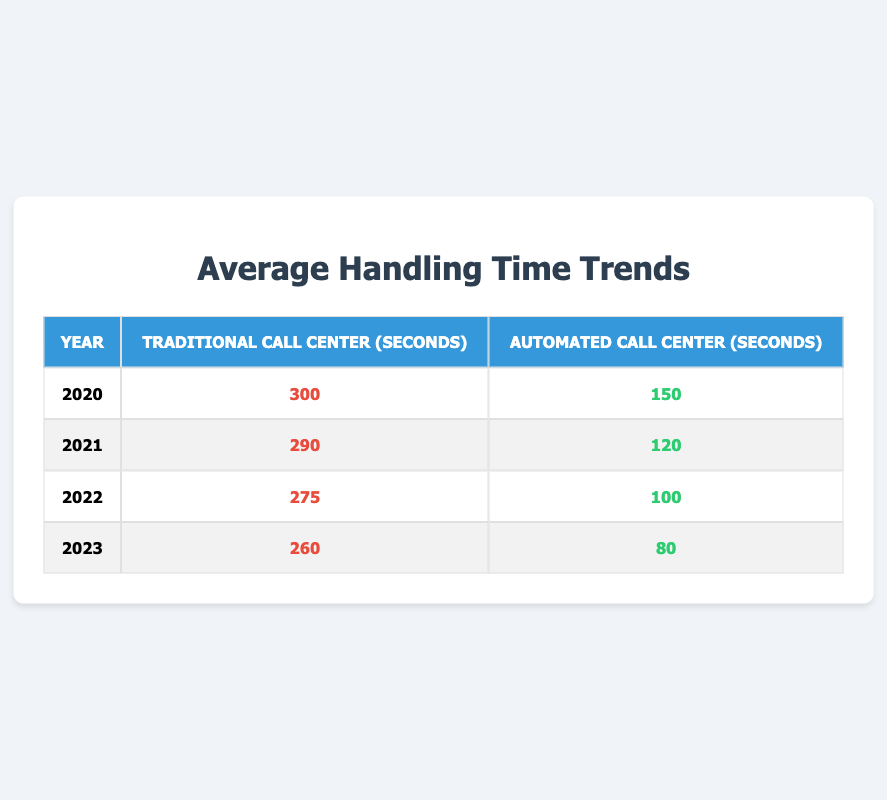What was the Average Handling Time for the Traditional Call Center in 2022? According to the table, the Average Handling Time for the Traditional Call Center in 2022 is listed as 275 seconds.
Answer: 275 seconds What was the Average Handling Time for the Automated Call Center in 2021? The table shows that the Average Handling Time for the Automated Call Center in 2021 is 120 seconds.
Answer: 120 seconds In which year did the Automated Call Center have its lowest Average Handling Time? The table indicates that the Automated Call Center had its lowest Average Handling Time in 2023, with a value of 80 seconds.
Answer: 2023 What is the difference in Average Handling Time between Traditional and Automated Call Centers in 2020? In 2020, the Average Handling Time for the Traditional Call Center was 300 seconds and for the Automated Call Center was 150 seconds. The difference is 300 - 150 = 150 seconds.
Answer: 150 seconds What is the average Average Handling Time for the Traditional Call Center over the years presented? The values for the Traditional Call Center are 300, 290, 275, and 260 seconds. The average is (300 + 290 + 275 + 260) / 4 = 271.25 seconds.
Answer: 271.25 seconds Is the Average Handling Time for the Automated Call Center lower in 2023 compared to 2021? The Automated Call Center had an Average Handling Time of 80 seconds in 2023 and 120 seconds in 2021. Since 80 < 120, the statement is true.
Answer: Yes What trend can be observed in the Average Handling Time for both call center types over the years? The table shows that both call center types have a downward trend in Average Handling Time from 2020 to 2023. For Traditional, it decreased from 300 to 260 seconds, and for Automated, it decreased from 150 to 80 seconds.
Answer: A downward trend What was the Average Handling Time for both types of call centers combined in 2022? To find the combined Average Handling Time in 2022, we compute the average of 275 seconds for Traditional and 100 seconds for Automated, which totals (275 + 100) / 2 = 187.5 seconds.
Answer: 187.5 seconds Which call center type consistently showed a lower Average Handling Time from 2020 to 2023? The table shows that the Automated Call Center had lower Average Handling Times than the Traditional Call Center every year from 2020 to 2023, confirming that it consistently showed lower times.
Answer: Automated Call Center What is the percentage decrease in Average Handling Time for the Traditional Call Center from 2020 to 2023? The Average Handling Time for the Traditional Call Center decreased from 300 seconds in 2020 to 260 seconds in 2023. The percentage decrease is calculated as ((300 - 260) / 300) * 100 = 13.33%.
Answer: 13.33% 